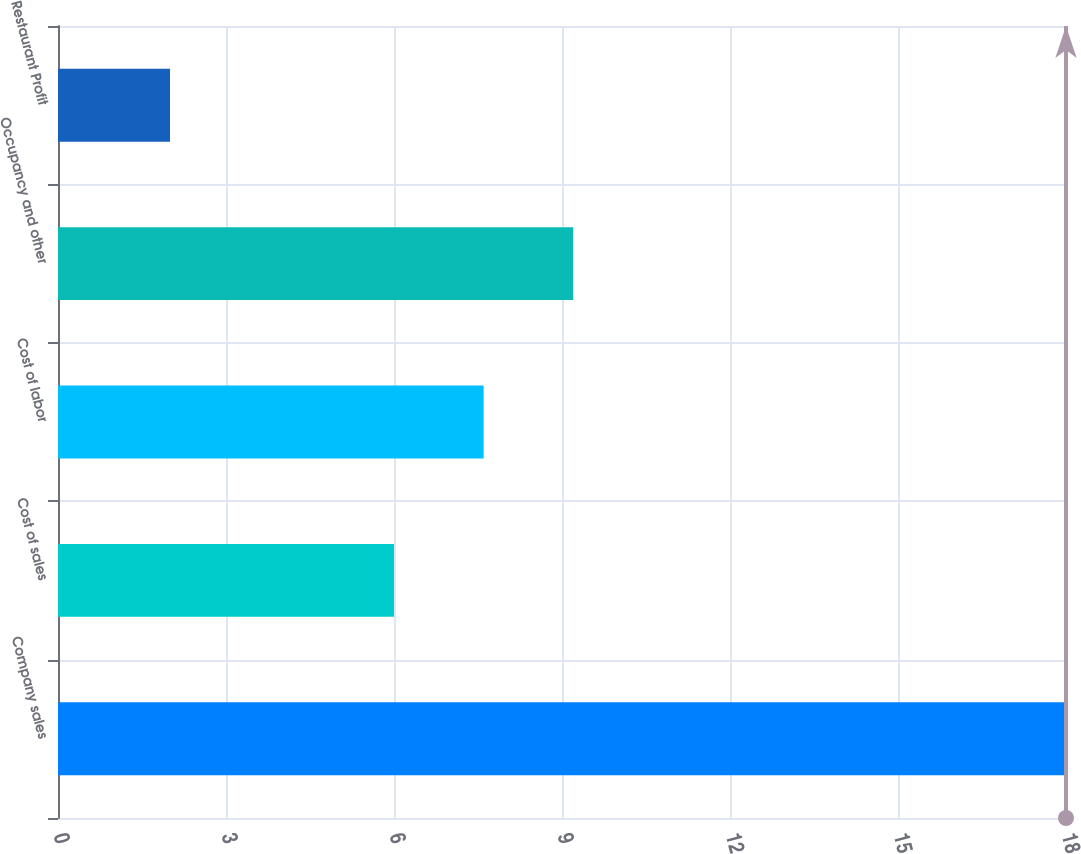Convert chart. <chart><loc_0><loc_0><loc_500><loc_500><bar_chart><fcel>Company sales<fcel>Cost of sales<fcel>Cost of labor<fcel>Occupancy and other<fcel>Restaurant Profit<nl><fcel>18<fcel>6<fcel>7.6<fcel>9.2<fcel>2<nl></chart> 